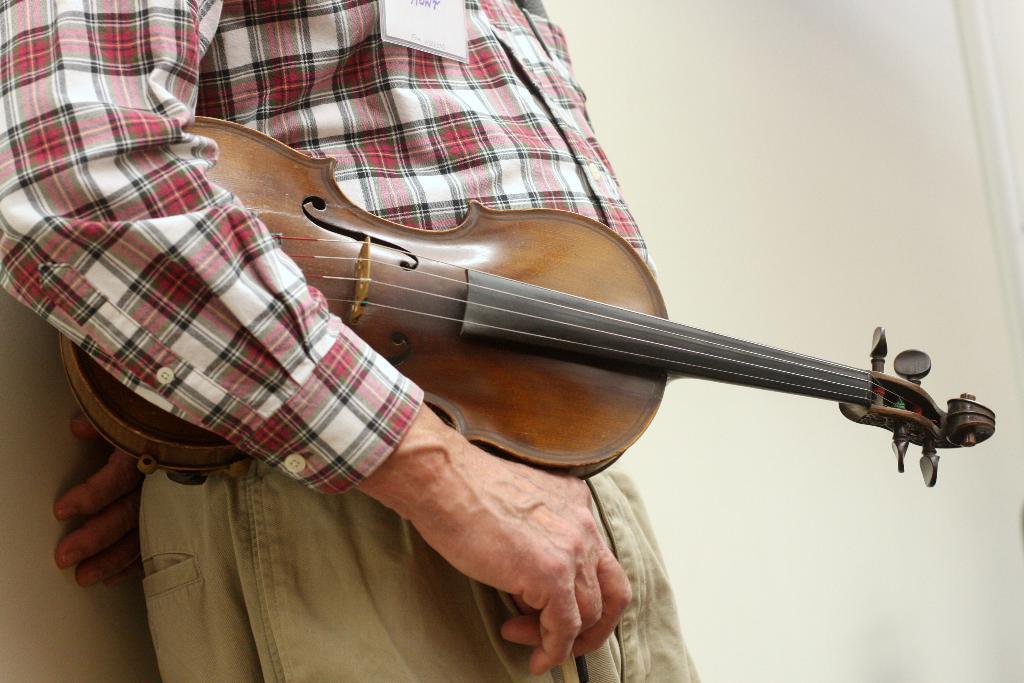How would you summarize this image in a sentence or two? This person holding musical instrument. On the background we can see wall. 